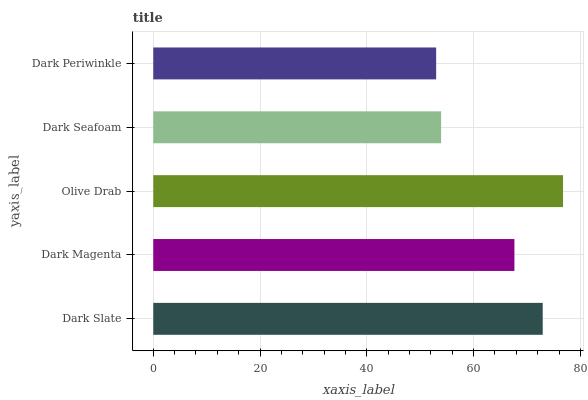Is Dark Periwinkle the minimum?
Answer yes or no. Yes. Is Olive Drab the maximum?
Answer yes or no. Yes. Is Dark Magenta the minimum?
Answer yes or no. No. Is Dark Magenta the maximum?
Answer yes or no. No. Is Dark Slate greater than Dark Magenta?
Answer yes or no. Yes. Is Dark Magenta less than Dark Slate?
Answer yes or no. Yes. Is Dark Magenta greater than Dark Slate?
Answer yes or no. No. Is Dark Slate less than Dark Magenta?
Answer yes or no. No. Is Dark Magenta the high median?
Answer yes or no. Yes. Is Dark Magenta the low median?
Answer yes or no. Yes. Is Dark Slate the high median?
Answer yes or no. No. Is Dark Seafoam the low median?
Answer yes or no. No. 